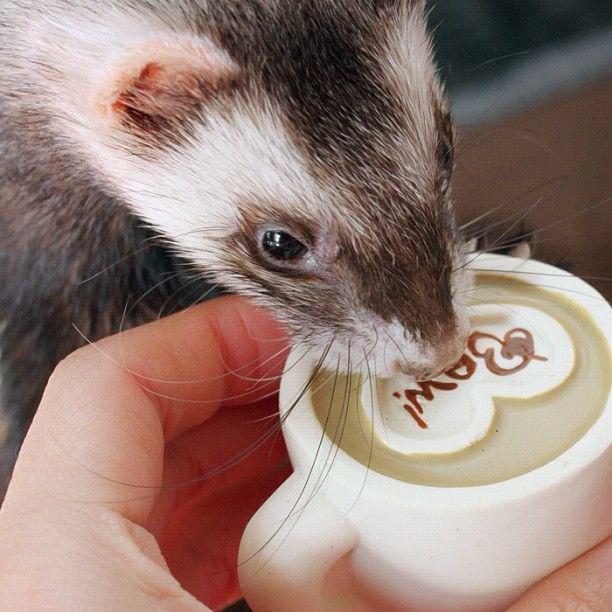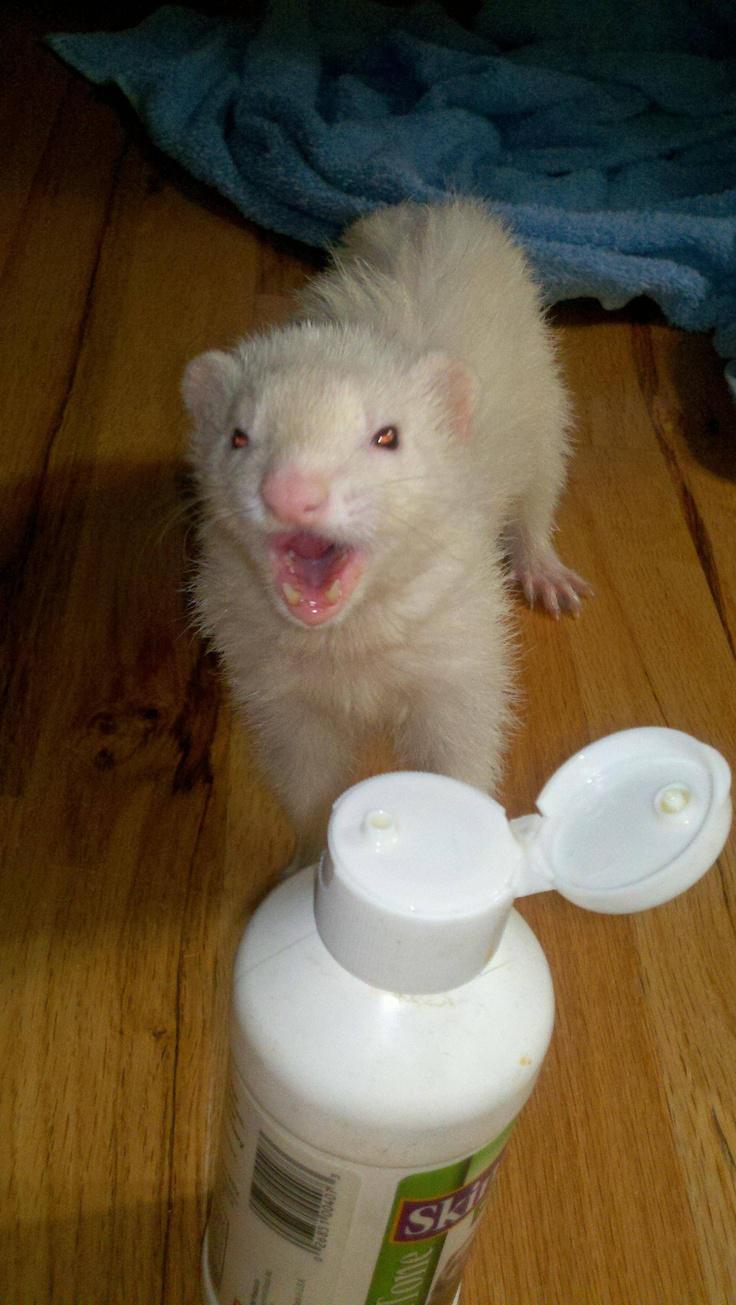The first image is the image on the left, the second image is the image on the right. Assess this claim about the two images: "The right image contains exactly one ferret.". Correct or not? Answer yes or no. Yes. The first image is the image on the left, the second image is the image on the right. Analyze the images presented: Is the assertion "Some ferrets are in a container." valid? Answer yes or no. No. 